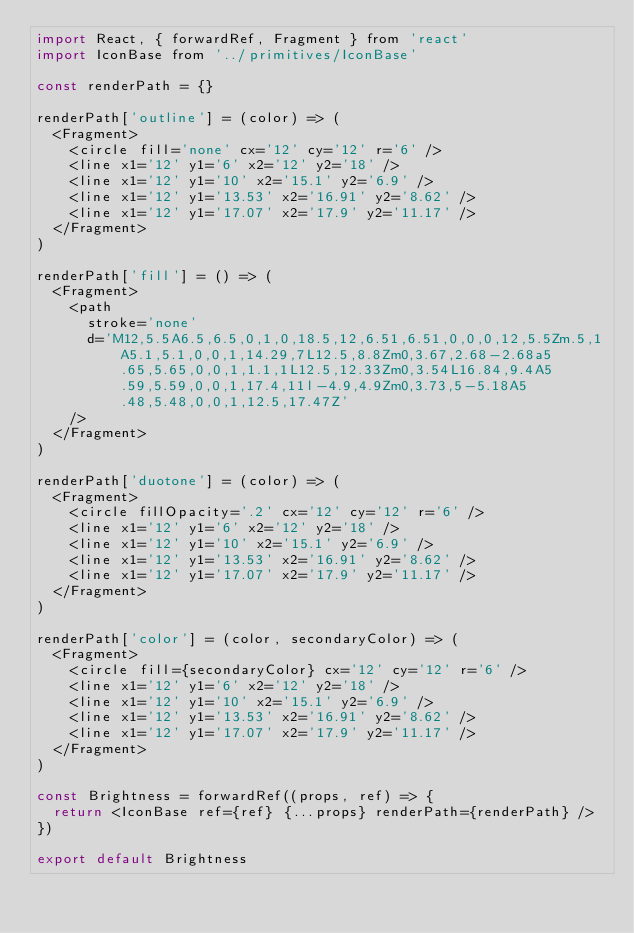Convert code to text. <code><loc_0><loc_0><loc_500><loc_500><_JavaScript_>import React, { forwardRef, Fragment } from 'react'
import IconBase from '../primitives/IconBase'

const renderPath = {}

renderPath['outline'] = (color) => (
  <Fragment>
    <circle fill='none' cx='12' cy='12' r='6' />
    <line x1='12' y1='6' x2='12' y2='18' />
    <line x1='12' y1='10' x2='15.1' y2='6.9' />
    <line x1='12' y1='13.53' x2='16.91' y2='8.62' />
    <line x1='12' y1='17.07' x2='17.9' y2='11.17' />
  </Fragment>
)

renderPath['fill'] = () => (
  <Fragment>
    <path
      stroke='none'
      d='M12,5.5A6.5,6.5,0,1,0,18.5,12,6.51,6.51,0,0,0,12,5.5Zm.5,1A5.1,5.1,0,0,1,14.29,7L12.5,8.8Zm0,3.67,2.68-2.68a5.65,5.65,0,0,1,1.1,1L12.5,12.33Zm0,3.54L16.84,9.4A5.59,5.59,0,0,1,17.4,11l-4.9,4.9Zm0,3.73,5-5.18A5.48,5.48,0,0,1,12.5,17.47Z'
    />
  </Fragment>
)

renderPath['duotone'] = (color) => (
  <Fragment>
    <circle fillOpacity='.2' cx='12' cy='12' r='6' />
    <line x1='12' y1='6' x2='12' y2='18' />
    <line x1='12' y1='10' x2='15.1' y2='6.9' />
    <line x1='12' y1='13.53' x2='16.91' y2='8.62' />
    <line x1='12' y1='17.07' x2='17.9' y2='11.17' />
  </Fragment>
)

renderPath['color'] = (color, secondaryColor) => (
  <Fragment>
    <circle fill={secondaryColor} cx='12' cy='12' r='6' />
    <line x1='12' y1='6' x2='12' y2='18' />
    <line x1='12' y1='10' x2='15.1' y2='6.9' />
    <line x1='12' y1='13.53' x2='16.91' y2='8.62' />
    <line x1='12' y1='17.07' x2='17.9' y2='11.17' />
  </Fragment>
)

const Brightness = forwardRef((props, ref) => {
  return <IconBase ref={ref} {...props} renderPath={renderPath} />
})

export default Brightness
</code> 